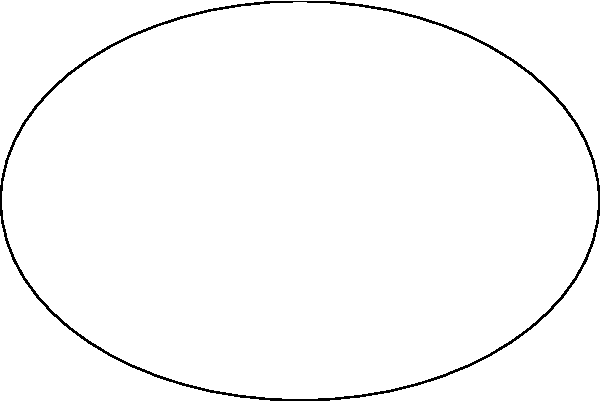As a spa owner, you're designing a new elliptical hot tub. The tub's shape can be described by the equation $\frac{x^2}{9} + \frac{y^2}{4} = 1$, where measurements are in meters. What is the area of this hot tub in square meters? To find the area of the elliptical hot tub, we'll follow these steps:

1) The general equation of an ellipse is $\frac{x^2}{a^2} + \frac{y^2}{b^2} = 1$, where $a$ and $b$ are the lengths of the semi-major and semi-minor axes.

2) Comparing our equation $\frac{x^2}{9} + \frac{y^2}{4} = 1$ to the general form, we can see that:
   $a^2 = 9$, so $a = 3$
   $b^2 = 4$, so $b = 2$

3) The formula for the area of an ellipse is $A = \pi ab$

4) Substituting our values:
   $A = \pi(3)(2)$
   $A = 6\pi$

5) If we want to give a decimal approximation:
   $A \approx 18.85$ square meters (rounded to two decimal places)

Therefore, the area of the hot tub is $6\pi$ or approximately 18.85 square meters.
Answer: $6\pi$ square meters 